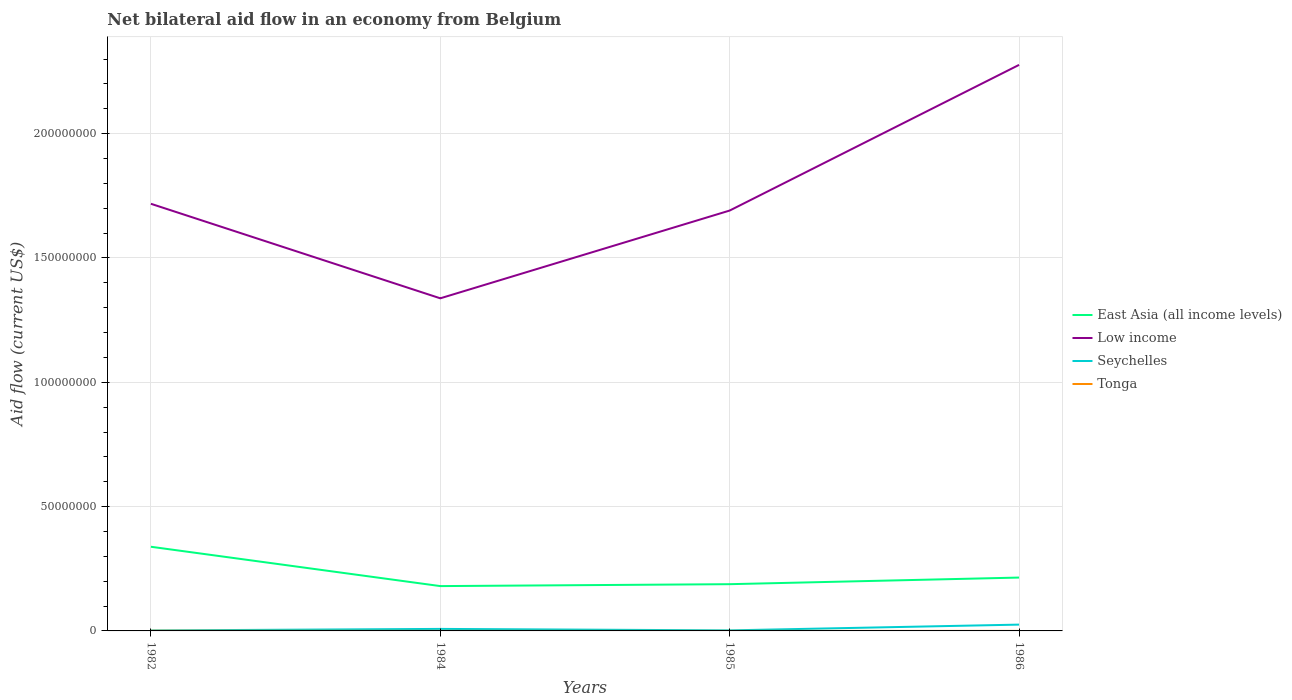Is the number of lines equal to the number of legend labels?
Give a very brief answer. Yes. Across all years, what is the maximum net bilateral aid flow in Low income?
Your response must be concise. 1.34e+08. What is the total net bilateral aid flow in Low income in the graph?
Your response must be concise. -3.53e+07. What is the difference between the highest and the second highest net bilateral aid flow in Tonga?
Provide a short and direct response. 6.00e+04. What is the difference between the highest and the lowest net bilateral aid flow in Low income?
Provide a short and direct response. 1. Is the net bilateral aid flow in Low income strictly greater than the net bilateral aid flow in Seychelles over the years?
Your answer should be very brief. No. What is the difference between two consecutive major ticks on the Y-axis?
Give a very brief answer. 5.00e+07. Are the values on the major ticks of Y-axis written in scientific E-notation?
Your response must be concise. No. Does the graph contain any zero values?
Provide a short and direct response. No. Does the graph contain grids?
Provide a short and direct response. Yes. How many legend labels are there?
Keep it short and to the point. 4. How are the legend labels stacked?
Provide a short and direct response. Vertical. What is the title of the graph?
Offer a terse response. Net bilateral aid flow in an economy from Belgium. Does "Saudi Arabia" appear as one of the legend labels in the graph?
Offer a very short reply. No. What is the label or title of the X-axis?
Your answer should be compact. Years. What is the label or title of the Y-axis?
Ensure brevity in your answer.  Aid flow (current US$). What is the Aid flow (current US$) in East Asia (all income levels) in 1982?
Your answer should be compact. 3.38e+07. What is the Aid flow (current US$) of Low income in 1982?
Provide a short and direct response. 1.72e+08. What is the Aid flow (current US$) of East Asia (all income levels) in 1984?
Provide a short and direct response. 1.80e+07. What is the Aid flow (current US$) of Low income in 1984?
Ensure brevity in your answer.  1.34e+08. What is the Aid flow (current US$) of Seychelles in 1984?
Ensure brevity in your answer.  8.10e+05. What is the Aid flow (current US$) in East Asia (all income levels) in 1985?
Offer a very short reply. 1.88e+07. What is the Aid flow (current US$) of Low income in 1985?
Your answer should be compact. 1.69e+08. What is the Aid flow (current US$) of Tonga in 1985?
Ensure brevity in your answer.  10000. What is the Aid flow (current US$) of East Asia (all income levels) in 1986?
Make the answer very short. 2.15e+07. What is the Aid flow (current US$) in Low income in 1986?
Provide a short and direct response. 2.28e+08. What is the Aid flow (current US$) of Seychelles in 1986?
Your answer should be compact. 2.54e+06. What is the Aid flow (current US$) in Tonga in 1986?
Make the answer very short. 10000. Across all years, what is the maximum Aid flow (current US$) in East Asia (all income levels)?
Provide a succinct answer. 3.38e+07. Across all years, what is the maximum Aid flow (current US$) of Low income?
Your answer should be very brief. 2.28e+08. Across all years, what is the maximum Aid flow (current US$) of Seychelles?
Provide a short and direct response. 2.54e+06. Across all years, what is the minimum Aid flow (current US$) of East Asia (all income levels)?
Your answer should be very brief. 1.80e+07. Across all years, what is the minimum Aid flow (current US$) in Low income?
Your answer should be compact. 1.34e+08. Across all years, what is the minimum Aid flow (current US$) of Tonga?
Ensure brevity in your answer.  10000. What is the total Aid flow (current US$) in East Asia (all income levels) in the graph?
Keep it short and to the point. 9.21e+07. What is the total Aid flow (current US$) of Low income in the graph?
Your answer should be compact. 7.02e+08. What is the total Aid flow (current US$) in Seychelles in the graph?
Make the answer very short. 3.76e+06. What is the total Aid flow (current US$) of Tonga in the graph?
Offer a terse response. 1.00e+05. What is the difference between the Aid flow (current US$) in East Asia (all income levels) in 1982 and that in 1984?
Give a very brief answer. 1.58e+07. What is the difference between the Aid flow (current US$) of Low income in 1982 and that in 1984?
Offer a very short reply. 3.80e+07. What is the difference between the Aid flow (current US$) in Seychelles in 1982 and that in 1984?
Ensure brevity in your answer.  -6.20e+05. What is the difference between the Aid flow (current US$) in Tonga in 1982 and that in 1984?
Offer a terse response. 6.00e+04. What is the difference between the Aid flow (current US$) in East Asia (all income levels) in 1982 and that in 1985?
Make the answer very short. 1.50e+07. What is the difference between the Aid flow (current US$) in Low income in 1982 and that in 1985?
Make the answer very short. 2.72e+06. What is the difference between the Aid flow (current US$) of Seychelles in 1982 and that in 1985?
Ensure brevity in your answer.  -3.00e+04. What is the difference between the Aid flow (current US$) in East Asia (all income levels) in 1982 and that in 1986?
Provide a succinct answer. 1.24e+07. What is the difference between the Aid flow (current US$) in Low income in 1982 and that in 1986?
Offer a terse response. -5.59e+07. What is the difference between the Aid flow (current US$) in Seychelles in 1982 and that in 1986?
Keep it short and to the point. -2.35e+06. What is the difference between the Aid flow (current US$) in East Asia (all income levels) in 1984 and that in 1985?
Make the answer very short. -7.70e+05. What is the difference between the Aid flow (current US$) of Low income in 1984 and that in 1985?
Offer a very short reply. -3.53e+07. What is the difference between the Aid flow (current US$) of Seychelles in 1984 and that in 1985?
Your answer should be compact. 5.90e+05. What is the difference between the Aid flow (current US$) of East Asia (all income levels) in 1984 and that in 1986?
Give a very brief answer. -3.43e+06. What is the difference between the Aid flow (current US$) in Low income in 1984 and that in 1986?
Give a very brief answer. -9.39e+07. What is the difference between the Aid flow (current US$) in Seychelles in 1984 and that in 1986?
Give a very brief answer. -1.73e+06. What is the difference between the Aid flow (current US$) in East Asia (all income levels) in 1985 and that in 1986?
Provide a short and direct response. -2.66e+06. What is the difference between the Aid flow (current US$) in Low income in 1985 and that in 1986?
Keep it short and to the point. -5.86e+07. What is the difference between the Aid flow (current US$) in Seychelles in 1985 and that in 1986?
Give a very brief answer. -2.32e+06. What is the difference between the Aid flow (current US$) of East Asia (all income levels) in 1982 and the Aid flow (current US$) of Low income in 1984?
Offer a very short reply. -9.99e+07. What is the difference between the Aid flow (current US$) in East Asia (all income levels) in 1982 and the Aid flow (current US$) in Seychelles in 1984?
Offer a terse response. 3.30e+07. What is the difference between the Aid flow (current US$) of East Asia (all income levels) in 1982 and the Aid flow (current US$) of Tonga in 1984?
Make the answer very short. 3.38e+07. What is the difference between the Aid flow (current US$) of Low income in 1982 and the Aid flow (current US$) of Seychelles in 1984?
Give a very brief answer. 1.71e+08. What is the difference between the Aid flow (current US$) of Low income in 1982 and the Aid flow (current US$) of Tonga in 1984?
Your answer should be very brief. 1.72e+08. What is the difference between the Aid flow (current US$) in East Asia (all income levels) in 1982 and the Aid flow (current US$) in Low income in 1985?
Give a very brief answer. -1.35e+08. What is the difference between the Aid flow (current US$) in East Asia (all income levels) in 1982 and the Aid flow (current US$) in Seychelles in 1985?
Provide a succinct answer. 3.36e+07. What is the difference between the Aid flow (current US$) in East Asia (all income levels) in 1982 and the Aid flow (current US$) in Tonga in 1985?
Your answer should be very brief. 3.38e+07. What is the difference between the Aid flow (current US$) of Low income in 1982 and the Aid flow (current US$) of Seychelles in 1985?
Your response must be concise. 1.72e+08. What is the difference between the Aid flow (current US$) of Low income in 1982 and the Aid flow (current US$) of Tonga in 1985?
Provide a succinct answer. 1.72e+08. What is the difference between the Aid flow (current US$) of Seychelles in 1982 and the Aid flow (current US$) of Tonga in 1985?
Your answer should be very brief. 1.80e+05. What is the difference between the Aid flow (current US$) in East Asia (all income levels) in 1982 and the Aid flow (current US$) in Low income in 1986?
Your answer should be very brief. -1.94e+08. What is the difference between the Aid flow (current US$) of East Asia (all income levels) in 1982 and the Aid flow (current US$) of Seychelles in 1986?
Give a very brief answer. 3.13e+07. What is the difference between the Aid flow (current US$) in East Asia (all income levels) in 1982 and the Aid flow (current US$) in Tonga in 1986?
Your answer should be compact. 3.38e+07. What is the difference between the Aid flow (current US$) of Low income in 1982 and the Aid flow (current US$) of Seychelles in 1986?
Offer a very short reply. 1.69e+08. What is the difference between the Aid flow (current US$) of Low income in 1982 and the Aid flow (current US$) of Tonga in 1986?
Provide a short and direct response. 1.72e+08. What is the difference between the Aid flow (current US$) in Seychelles in 1982 and the Aid flow (current US$) in Tonga in 1986?
Give a very brief answer. 1.80e+05. What is the difference between the Aid flow (current US$) in East Asia (all income levels) in 1984 and the Aid flow (current US$) in Low income in 1985?
Offer a terse response. -1.51e+08. What is the difference between the Aid flow (current US$) of East Asia (all income levels) in 1984 and the Aid flow (current US$) of Seychelles in 1985?
Provide a succinct answer. 1.78e+07. What is the difference between the Aid flow (current US$) of East Asia (all income levels) in 1984 and the Aid flow (current US$) of Tonga in 1985?
Keep it short and to the point. 1.80e+07. What is the difference between the Aid flow (current US$) of Low income in 1984 and the Aid flow (current US$) of Seychelles in 1985?
Your response must be concise. 1.34e+08. What is the difference between the Aid flow (current US$) of Low income in 1984 and the Aid flow (current US$) of Tonga in 1985?
Offer a very short reply. 1.34e+08. What is the difference between the Aid flow (current US$) of East Asia (all income levels) in 1984 and the Aid flow (current US$) of Low income in 1986?
Provide a short and direct response. -2.10e+08. What is the difference between the Aid flow (current US$) in East Asia (all income levels) in 1984 and the Aid flow (current US$) in Seychelles in 1986?
Your answer should be very brief. 1.55e+07. What is the difference between the Aid flow (current US$) in East Asia (all income levels) in 1984 and the Aid flow (current US$) in Tonga in 1986?
Your answer should be very brief. 1.80e+07. What is the difference between the Aid flow (current US$) in Low income in 1984 and the Aid flow (current US$) in Seychelles in 1986?
Keep it short and to the point. 1.31e+08. What is the difference between the Aid flow (current US$) in Low income in 1984 and the Aid flow (current US$) in Tonga in 1986?
Provide a short and direct response. 1.34e+08. What is the difference between the Aid flow (current US$) of East Asia (all income levels) in 1985 and the Aid flow (current US$) of Low income in 1986?
Ensure brevity in your answer.  -2.09e+08. What is the difference between the Aid flow (current US$) in East Asia (all income levels) in 1985 and the Aid flow (current US$) in Seychelles in 1986?
Your response must be concise. 1.63e+07. What is the difference between the Aid flow (current US$) of East Asia (all income levels) in 1985 and the Aid flow (current US$) of Tonga in 1986?
Offer a very short reply. 1.88e+07. What is the difference between the Aid flow (current US$) of Low income in 1985 and the Aid flow (current US$) of Seychelles in 1986?
Make the answer very short. 1.67e+08. What is the difference between the Aid flow (current US$) of Low income in 1985 and the Aid flow (current US$) of Tonga in 1986?
Offer a very short reply. 1.69e+08. What is the average Aid flow (current US$) of East Asia (all income levels) per year?
Your response must be concise. 2.30e+07. What is the average Aid flow (current US$) of Low income per year?
Keep it short and to the point. 1.76e+08. What is the average Aid flow (current US$) of Seychelles per year?
Make the answer very short. 9.40e+05. What is the average Aid flow (current US$) of Tonga per year?
Make the answer very short. 2.50e+04. In the year 1982, what is the difference between the Aid flow (current US$) in East Asia (all income levels) and Aid flow (current US$) in Low income?
Keep it short and to the point. -1.38e+08. In the year 1982, what is the difference between the Aid flow (current US$) of East Asia (all income levels) and Aid flow (current US$) of Seychelles?
Ensure brevity in your answer.  3.37e+07. In the year 1982, what is the difference between the Aid flow (current US$) in East Asia (all income levels) and Aid flow (current US$) in Tonga?
Keep it short and to the point. 3.38e+07. In the year 1982, what is the difference between the Aid flow (current US$) of Low income and Aid flow (current US$) of Seychelles?
Make the answer very short. 1.72e+08. In the year 1982, what is the difference between the Aid flow (current US$) in Low income and Aid flow (current US$) in Tonga?
Offer a very short reply. 1.72e+08. In the year 1982, what is the difference between the Aid flow (current US$) of Seychelles and Aid flow (current US$) of Tonga?
Your answer should be compact. 1.20e+05. In the year 1984, what is the difference between the Aid flow (current US$) of East Asia (all income levels) and Aid flow (current US$) of Low income?
Offer a terse response. -1.16e+08. In the year 1984, what is the difference between the Aid flow (current US$) in East Asia (all income levels) and Aid flow (current US$) in Seychelles?
Offer a terse response. 1.72e+07. In the year 1984, what is the difference between the Aid flow (current US$) in East Asia (all income levels) and Aid flow (current US$) in Tonga?
Give a very brief answer. 1.80e+07. In the year 1984, what is the difference between the Aid flow (current US$) of Low income and Aid flow (current US$) of Seychelles?
Provide a short and direct response. 1.33e+08. In the year 1984, what is the difference between the Aid flow (current US$) of Low income and Aid flow (current US$) of Tonga?
Make the answer very short. 1.34e+08. In the year 1984, what is the difference between the Aid flow (current US$) of Seychelles and Aid flow (current US$) of Tonga?
Provide a succinct answer. 8.00e+05. In the year 1985, what is the difference between the Aid flow (current US$) of East Asia (all income levels) and Aid flow (current US$) of Low income?
Give a very brief answer. -1.50e+08. In the year 1985, what is the difference between the Aid flow (current US$) in East Asia (all income levels) and Aid flow (current US$) in Seychelles?
Provide a succinct answer. 1.86e+07. In the year 1985, what is the difference between the Aid flow (current US$) of East Asia (all income levels) and Aid flow (current US$) of Tonga?
Provide a succinct answer. 1.88e+07. In the year 1985, what is the difference between the Aid flow (current US$) of Low income and Aid flow (current US$) of Seychelles?
Ensure brevity in your answer.  1.69e+08. In the year 1985, what is the difference between the Aid flow (current US$) in Low income and Aid flow (current US$) in Tonga?
Your response must be concise. 1.69e+08. In the year 1986, what is the difference between the Aid flow (current US$) in East Asia (all income levels) and Aid flow (current US$) in Low income?
Make the answer very short. -2.06e+08. In the year 1986, what is the difference between the Aid flow (current US$) in East Asia (all income levels) and Aid flow (current US$) in Seychelles?
Ensure brevity in your answer.  1.89e+07. In the year 1986, what is the difference between the Aid flow (current US$) in East Asia (all income levels) and Aid flow (current US$) in Tonga?
Your answer should be very brief. 2.14e+07. In the year 1986, what is the difference between the Aid flow (current US$) in Low income and Aid flow (current US$) in Seychelles?
Your response must be concise. 2.25e+08. In the year 1986, what is the difference between the Aid flow (current US$) of Low income and Aid flow (current US$) of Tonga?
Your answer should be very brief. 2.28e+08. In the year 1986, what is the difference between the Aid flow (current US$) in Seychelles and Aid flow (current US$) in Tonga?
Your answer should be very brief. 2.53e+06. What is the ratio of the Aid flow (current US$) in East Asia (all income levels) in 1982 to that in 1984?
Your answer should be very brief. 1.88. What is the ratio of the Aid flow (current US$) of Low income in 1982 to that in 1984?
Provide a succinct answer. 1.28. What is the ratio of the Aid flow (current US$) in Seychelles in 1982 to that in 1984?
Your answer should be very brief. 0.23. What is the ratio of the Aid flow (current US$) of Tonga in 1982 to that in 1984?
Offer a very short reply. 7. What is the ratio of the Aid flow (current US$) of East Asia (all income levels) in 1982 to that in 1985?
Give a very brief answer. 1.8. What is the ratio of the Aid flow (current US$) of Low income in 1982 to that in 1985?
Ensure brevity in your answer.  1.02. What is the ratio of the Aid flow (current US$) of Seychelles in 1982 to that in 1985?
Give a very brief answer. 0.86. What is the ratio of the Aid flow (current US$) of East Asia (all income levels) in 1982 to that in 1986?
Your answer should be compact. 1.58. What is the ratio of the Aid flow (current US$) in Low income in 1982 to that in 1986?
Ensure brevity in your answer.  0.75. What is the ratio of the Aid flow (current US$) in Seychelles in 1982 to that in 1986?
Your answer should be compact. 0.07. What is the ratio of the Aid flow (current US$) of Low income in 1984 to that in 1985?
Your response must be concise. 0.79. What is the ratio of the Aid flow (current US$) of Seychelles in 1984 to that in 1985?
Keep it short and to the point. 3.68. What is the ratio of the Aid flow (current US$) of East Asia (all income levels) in 1984 to that in 1986?
Your answer should be very brief. 0.84. What is the ratio of the Aid flow (current US$) of Low income in 1984 to that in 1986?
Offer a very short reply. 0.59. What is the ratio of the Aid flow (current US$) in Seychelles in 1984 to that in 1986?
Offer a terse response. 0.32. What is the ratio of the Aid flow (current US$) in Tonga in 1984 to that in 1986?
Provide a succinct answer. 1. What is the ratio of the Aid flow (current US$) in East Asia (all income levels) in 1985 to that in 1986?
Ensure brevity in your answer.  0.88. What is the ratio of the Aid flow (current US$) of Low income in 1985 to that in 1986?
Provide a succinct answer. 0.74. What is the ratio of the Aid flow (current US$) in Seychelles in 1985 to that in 1986?
Offer a very short reply. 0.09. What is the difference between the highest and the second highest Aid flow (current US$) in East Asia (all income levels)?
Your response must be concise. 1.24e+07. What is the difference between the highest and the second highest Aid flow (current US$) in Low income?
Your answer should be very brief. 5.59e+07. What is the difference between the highest and the second highest Aid flow (current US$) of Seychelles?
Your response must be concise. 1.73e+06. What is the difference between the highest and the second highest Aid flow (current US$) in Tonga?
Offer a very short reply. 6.00e+04. What is the difference between the highest and the lowest Aid flow (current US$) of East Asia (all income levels)?
Make the answer very short. 1.58e+07. What is the difference between the highest and the lowest Aid flow (current US$) in Low income?
Your answer should be compact. 9.39e+07. What is the difference between the highest and the lowest Aid flow (current US$) in Seychelles?
Your answer should be compact. 2.35e+06. What is the difference between the highest and the lowest Aid flow (current US$) of Tonga?
Make the answer very short. 6.00e+04. 